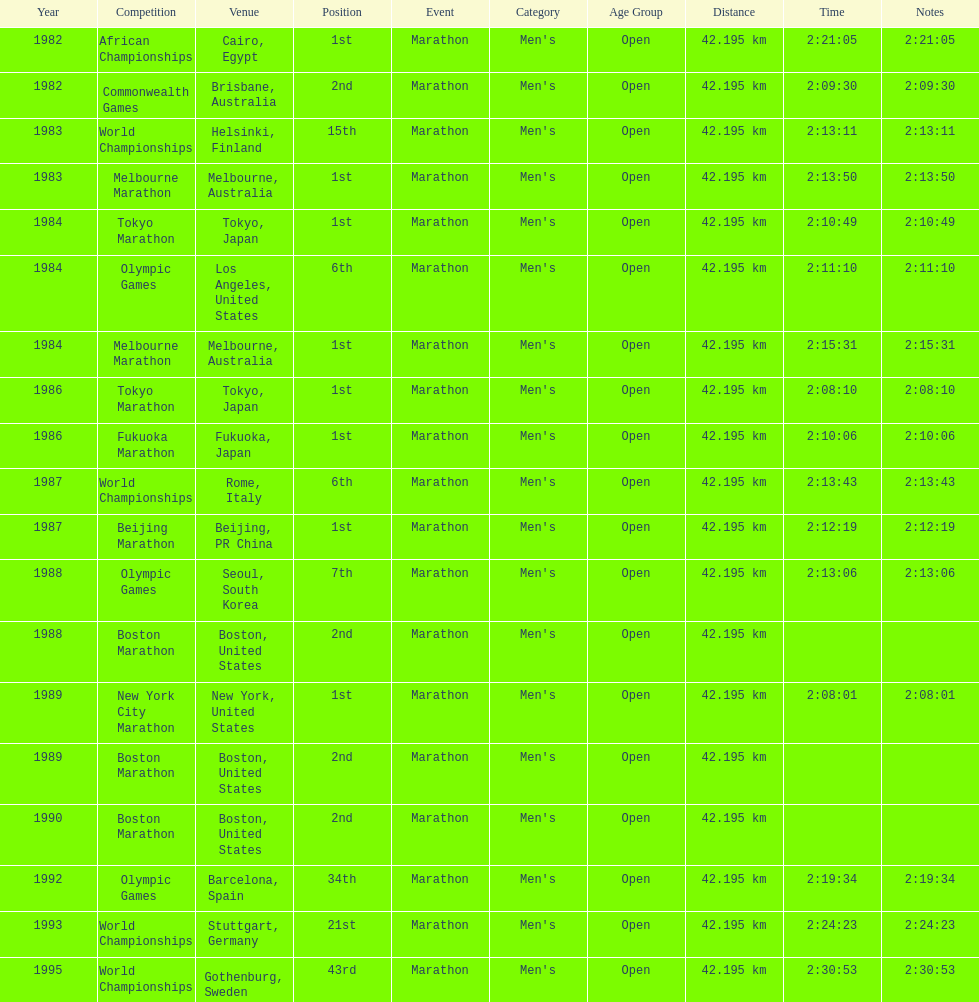Parse the full table. {'header': ['Year', 'Competition', 'Venue', 'Position', 'Event', 'Category', 'Age Group', 'Distance', 'Time', 'Notes'], 'rows': [['1982', 'African Championships', 'Cairo, Egypt', '1st', 'Marathon', "Men's", 'Open', '42.195 km', '2:21:05', '2:21:05'], ['1982', 'Commonwealth Games', 'Brisbane, Australia', '2nd', 'Marathon', "Men's", 'Open', '42.195 km', '2:09:30', '2:09:30'], ['1983', 'World Championships', 'Helsinki, Finland', '15th', 'Marathon', "Men's", 'Open', '42.195 km', '2:13:11', '2:13:11'], ['1983', 'Melbourne Marathon', 'Melbourne, Australia', '1st', 'Marathon', "Men's", 'Open', '42.195 km', '2:13:50', '2:13:50'], ['1984', 'Tokyo Marathon', 'Tokyo, Japan', '1st', 'Marathon', "Men's", 'Open', '42.195 km', '2:10:49', '2:10:49'], ['1984', 'Olympic Games', 'Los Angeles, United States', '6th', 'Marathon', "Men's", 'Open', '42.195 km', '2:11:10', '2:11:10'], ['1984', 'Melbourne Marathon', 'Melbourne, Australia', '1st', 'Marathon', "Men's", 'Open', '42.195 km', '2:15:31', '2:15:31'], ['1986', 'Tokyo Marathon', 'Tokyo, Japan', '1st', 'Marathon', "Men's", 'Open', '42.195 km', '2:08:10', '2:08:10'], ['1986', 'Fukuoka Marathon', 'Fukuoka, Japan', '1st', 'Marathon', "Men's", 'Open', '42.195 km', '2:10:06', '2:10:06'], ['1987', 'World Championships', 'Rome, Italy', '6th', 'Marathon', "Men's", 'Open', '42.195 km', '2:13:43', '2:13:43'], ['1987', 'Beijing Marathon', 'Beijing, PR China', '1st', 'Marathon', "Men's", 'Open', '42.195 km', '2:12:19', '2:12:19'], ['1988', 'Olympic Games', 'Seoul, South Korea', '7th', 'Marathon', "Men's", 'Open', '42.195 km', '2:13:06', '2:13:06'], ['1988', 'Boston Marathon', 'Boston, United States', '2nd', 'Marathon', "Men's", 'Open', '42.195 km', '', ''], ['1989', 'New York City Marathon', 'New York, United States', '1st', 'Marathon', "Men's", 'Open', '42.195 km', '2:08:01', '2:08:01'], ['1989', 'Boston Marathon', 'Boston, United States', '2nd', 'Marathon', "Men's", 'Open', '42.195 km', '', ''], ['1990', 'Boston Marathon', 'Boston, United States', '2nd', 'Marathon', "Men's", 'Open', '42.195 km', '', ''], ['1992', 'Olympic Games', 'Barcelona, Spain', '34th', 'Marathon', "Men's", 'Open', '42.195 km', '2:19:34', '2:19:34'], ['1993', 'World Championships', 'Stuttgart, Germany', '21st', 'Marathon', "Men's", 'Open', '42.195 km', '2:24:23', '2:24:23'], ['1995', 'World Championships', 'Gothenburg, Sweden', '43rd', 'Marathon', "Men's", 'Open', '42.195 km', '2:30:53', '2:30:53']]} Which was the only competition to occur in china? Beijing Marathon. 